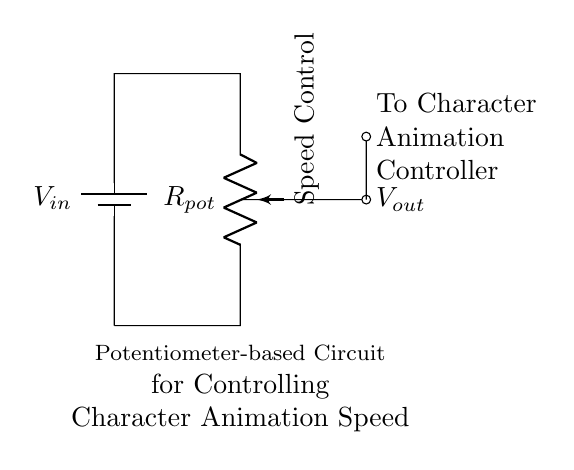What component is used for speed control? The circuit includes a potentiometer for adjusting the speed of character animation. The potentiometer allows variable resistance, controlling the output voltage based on its position.
Answer: Potentiometer What is the role of the battery in this circuit? The battery provides the necessary input voltage to the circuit. It establishes a potential difference that drives current through the potentiometer.
Answer: Input voltage What does V out represent in the circuit? V out is the voltage output taken from the potentiometer to control the character animation speed. It varies depending on the setting of the potentiometer.
Answer: Output voltage How does adjusting the potentiometer affect V out? Adjusting the potentiometer changes its resistance, which modifies the voltage drop across it, therefore altering the output voltage (V out) based on the voltage divider principle.
Answer: V out changes Is this circuit a type of voltage divider? Yes, this circuit functions as a voltage divider because it uses a potentiometer to split the input voltage into a lower output voltage based on the resistance set by the potentiometer.
Answer: Yes 